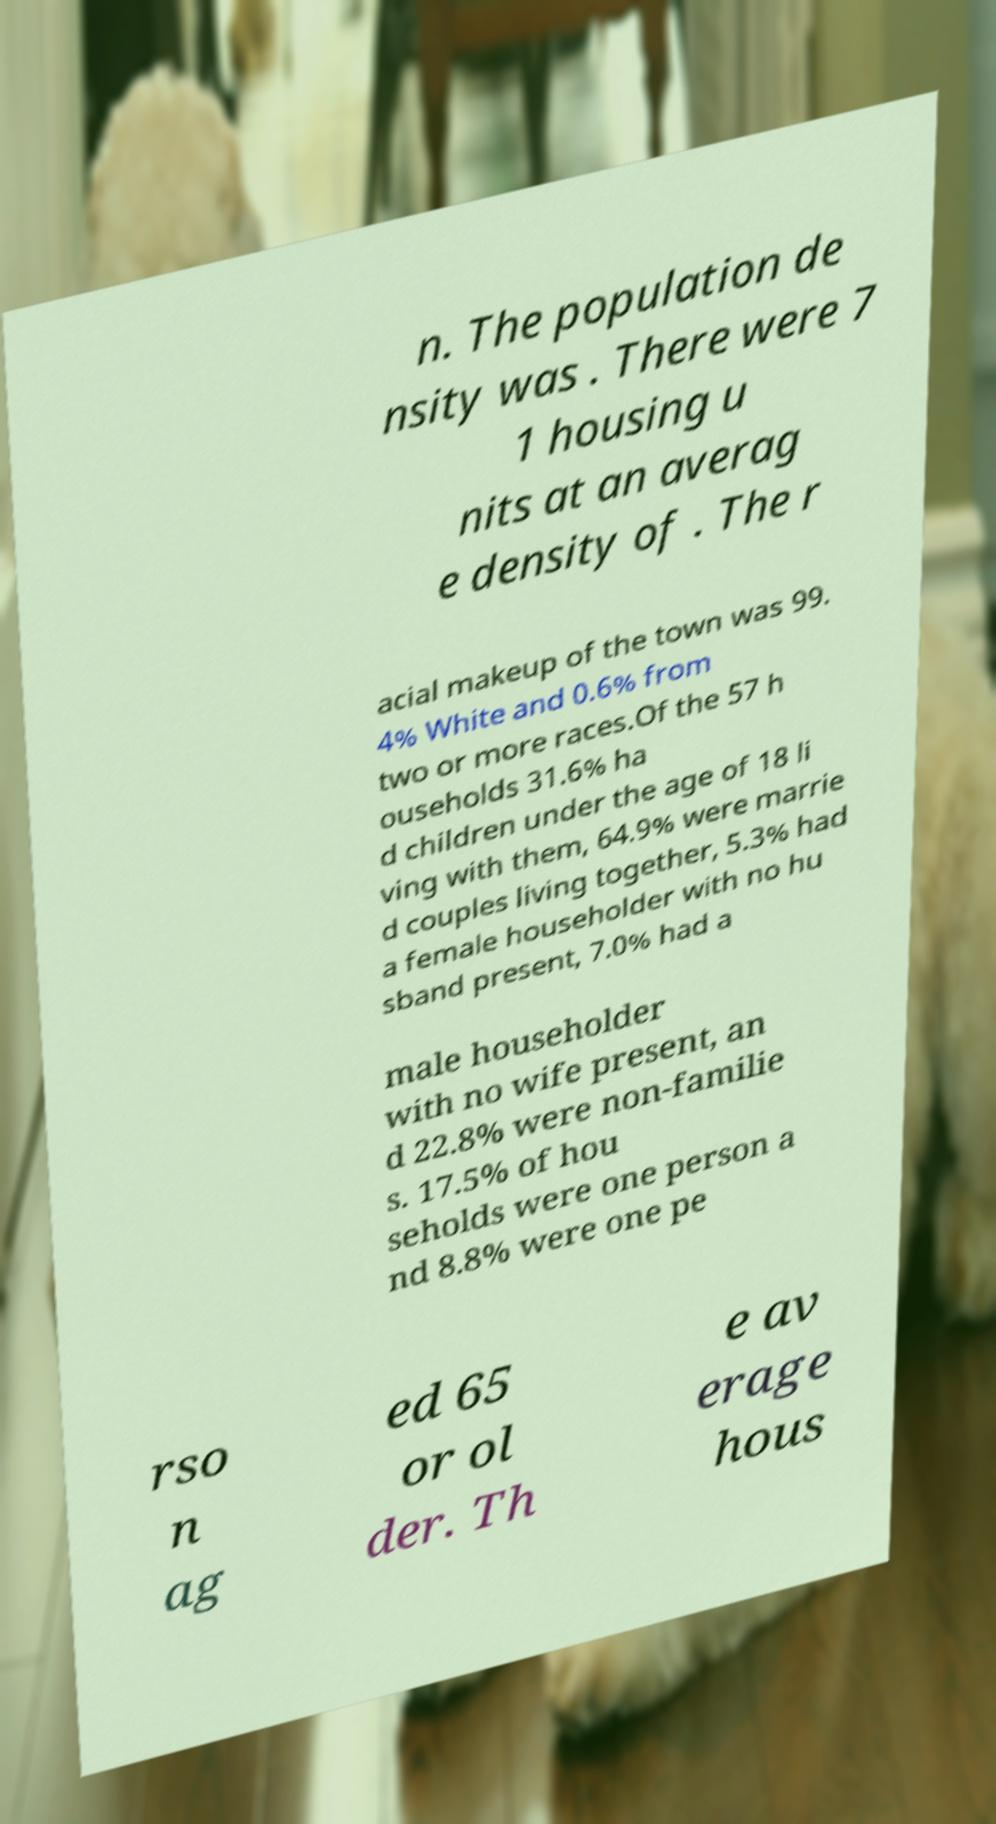Can you accurately transcribe the text from the provided image for me? n. The population de nsity was . There were 7 1 housing u nits at an averag e density of . The r acial makeup of the town was 99. 4% White and 0.6% from two or more races.Of the 57 h ouseholds 31.6% ha d children under the age of 18 li ving with them, 64.9% were marrie d couples living together, 5.3% had a female householder with no hu sband present, 7.0% had a male householder with no wife present, an d 22.8% were non-familie s. 17.5% of hou seholds were one person a nd 8.8% were one pe rso n ag ed 65 or ol der. Th e av erage hous 